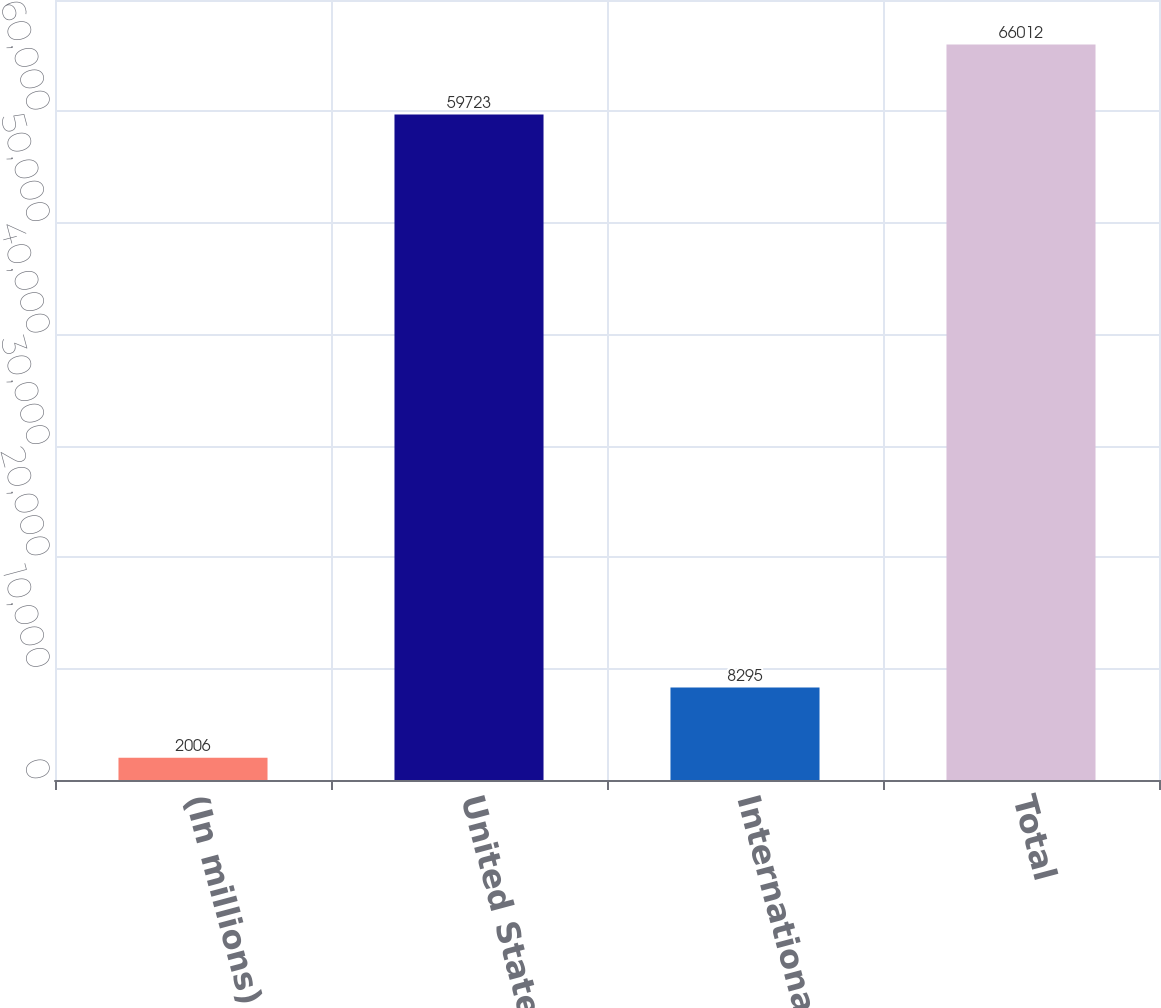Convert chart. <chart><loc_0><loc_0><loc_500><loc_500><bar_chart><fcel>(In millions)<fcel>United States<fcel>International<fcel>Total<nl><fcel>2006<fcel>59723<fcel>8295<fcel>66012<nl></chart> 